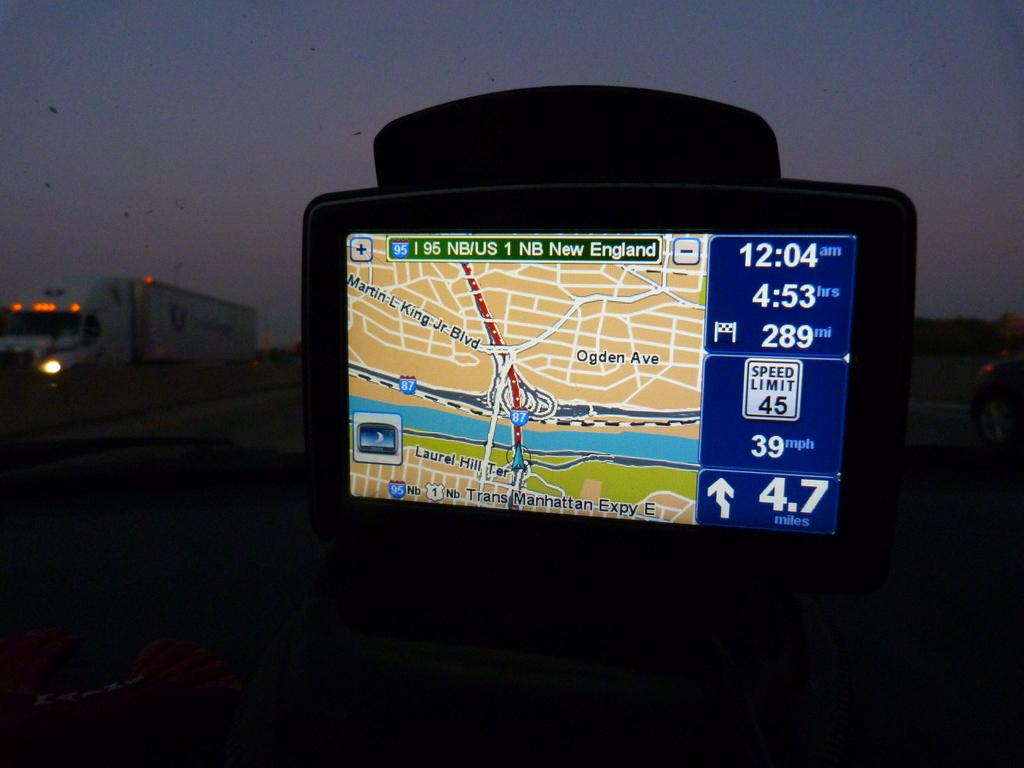What is the main subject of the image? There is a device in the image. What can be seen in the background of the image? Vehicles and the sky are visible in the background of the image. How does the passenger feel about the poison in the image? There is no passenger or poison present in the image. 